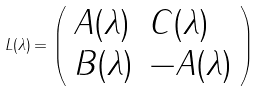Convert formula to latex. <formula><loc_0><loc_0><loc_500><loc_500>L ( \lambda ) = \left ( \begin{array} { l l } { A ( \lambda ) } & { C ( \lambda ) } \\ { B ( \lambda ) } & { - A ( \lambda ) } \end{array} \right )</formula> 